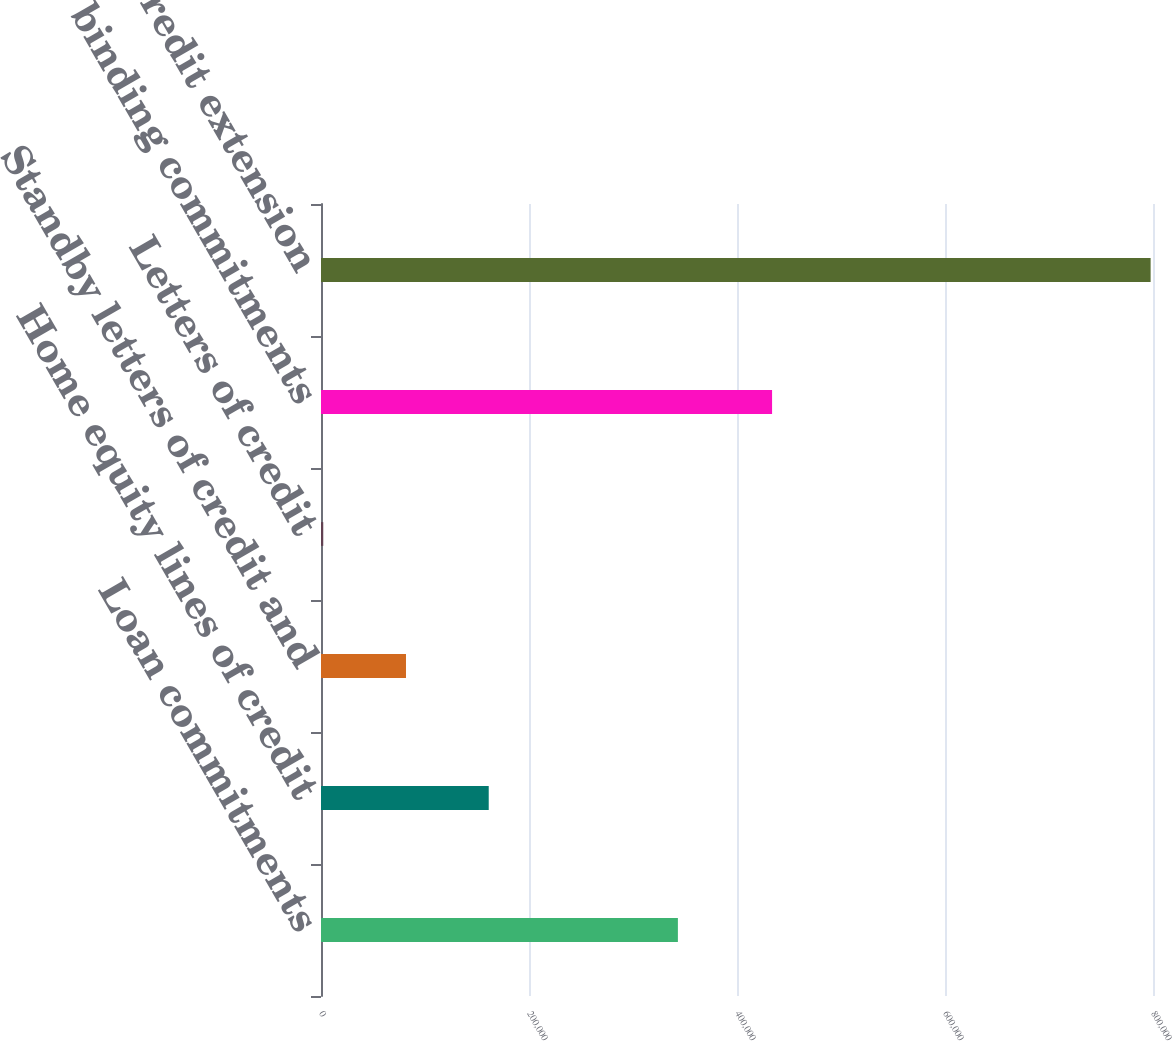Convert chart. <chart><loc_0><loc_0><loc_500><loc_500><bar_chart><fcel>Loan commitments<fcel>Home equity lines of credit<fcel>Standby letters of credit and<fcel>Letters of credit<fcel>Legally binding commitments<fcel>Total credit extension<nl><fcel>343165<fcel>161273<fcel>81718.2<fcel>2163<fcel>433726<fcel>797715<nl></chart> 